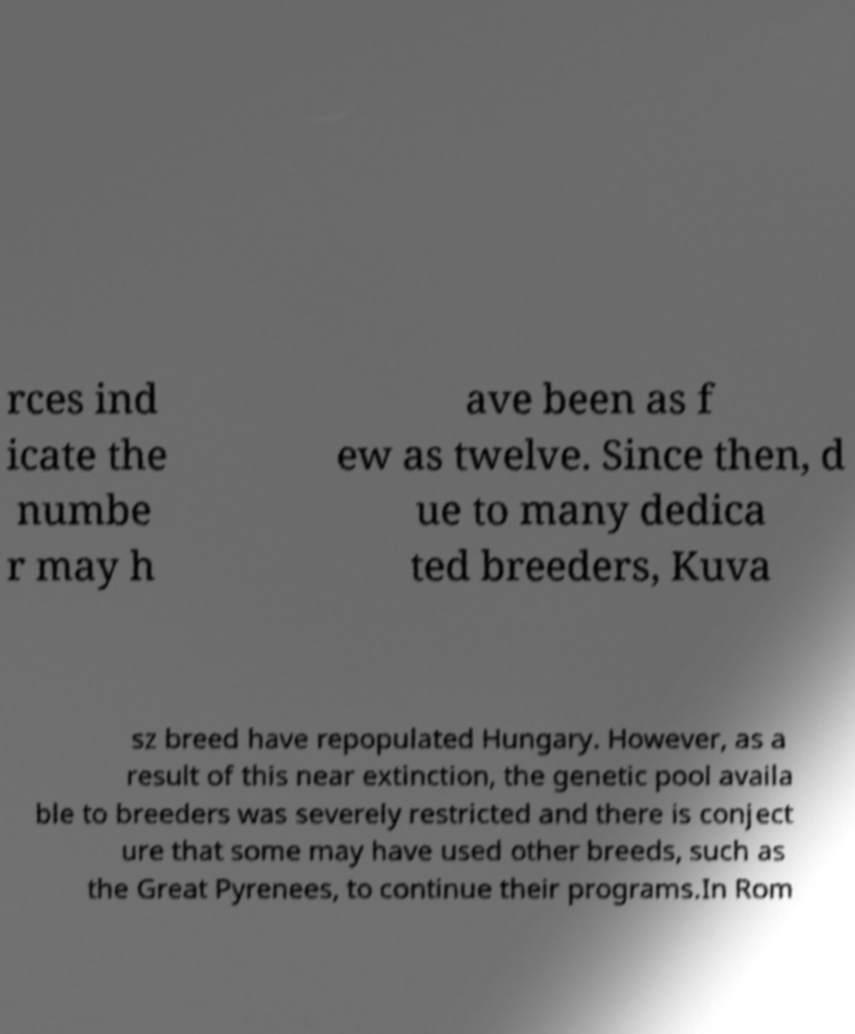Can you accurately transcribe the text from the provided image for me? rces ind icate the numbe r may h ave been as f ew as twelve. Since then, d ue to many dedica ted breeders, Kuva sz breed have repopulated Hungary. However, as a result of this near extinction, the genetic pool availa ble to breeders was severely restricted and there is conject ure that some may have used other breeds, such as the Great Pyrenees, to continue their programs.In Rom 